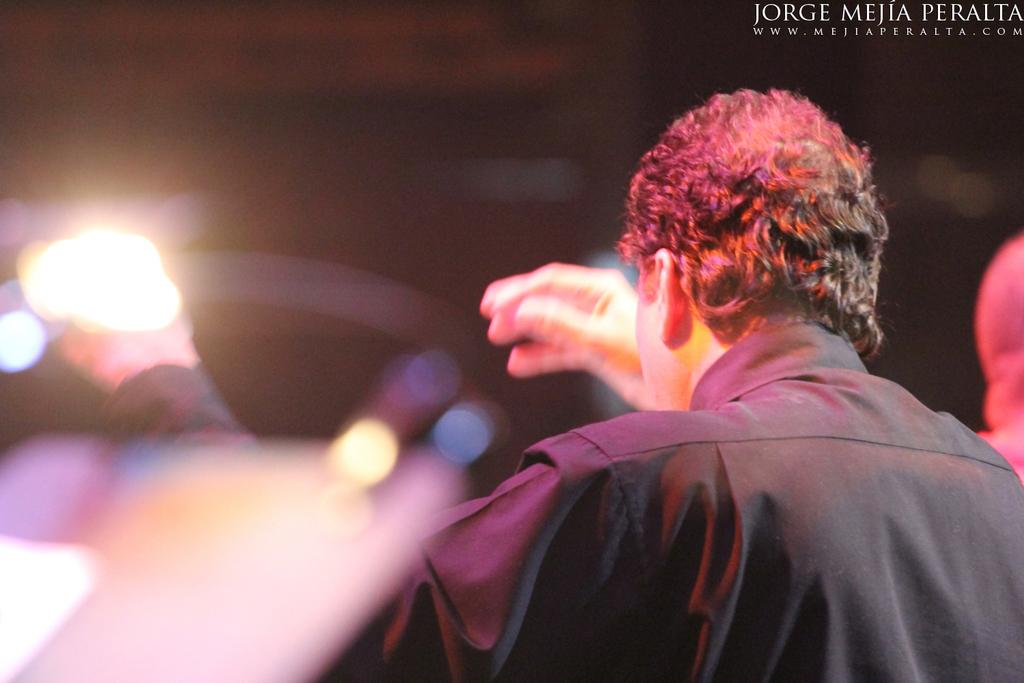What is the main subject of the image? The main subject of the image is a man. What is the man wearing in the image? The man is wearing a black color shirt in the image. What type of cast can be seen on the man's arm in the image? There is no cast visible on the man's arm in the image. What answer is the man providing in the image? There is no indication in the image that the man is providing an answer to a question or statement. 